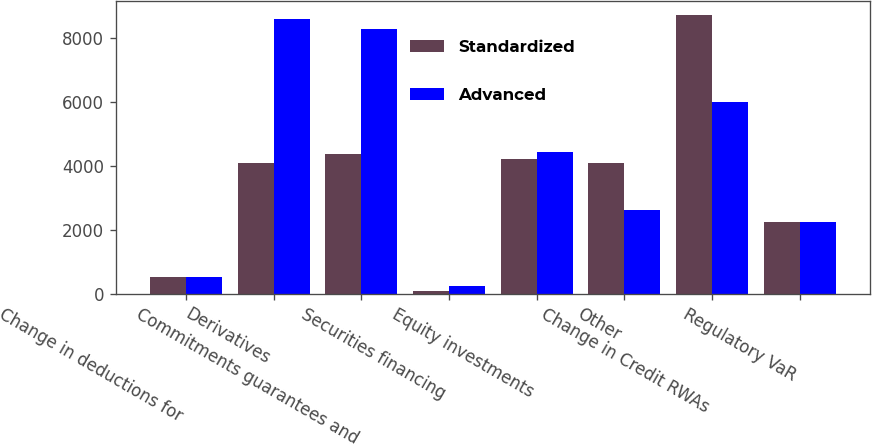Convert chart. <chart><loc_0><loc_0><loc_500><loc_500><stacked_bar_chart><ecel><fcel>Change in deductions for<fcel>Derivatives<fcel>Commitments guarantees and<fcel>Securities financing<fcel>Equity investments<fcel>Other<fcel>Change in Credit RWAs<fcel>Regulatory VaR<nl><fcel>Standardized<fcel>531<fcel>4095<fcel>4353<fcel>73<fcel>4196<fcel>4095<fcel>8705<fcel>2250<nl><fcel>Advanced<fcel>531<fcel>8575<fcel>8269<fcel>228<fcel>4440<fcel>2630<fcel>6005<fcel>2250<nl></chart> 